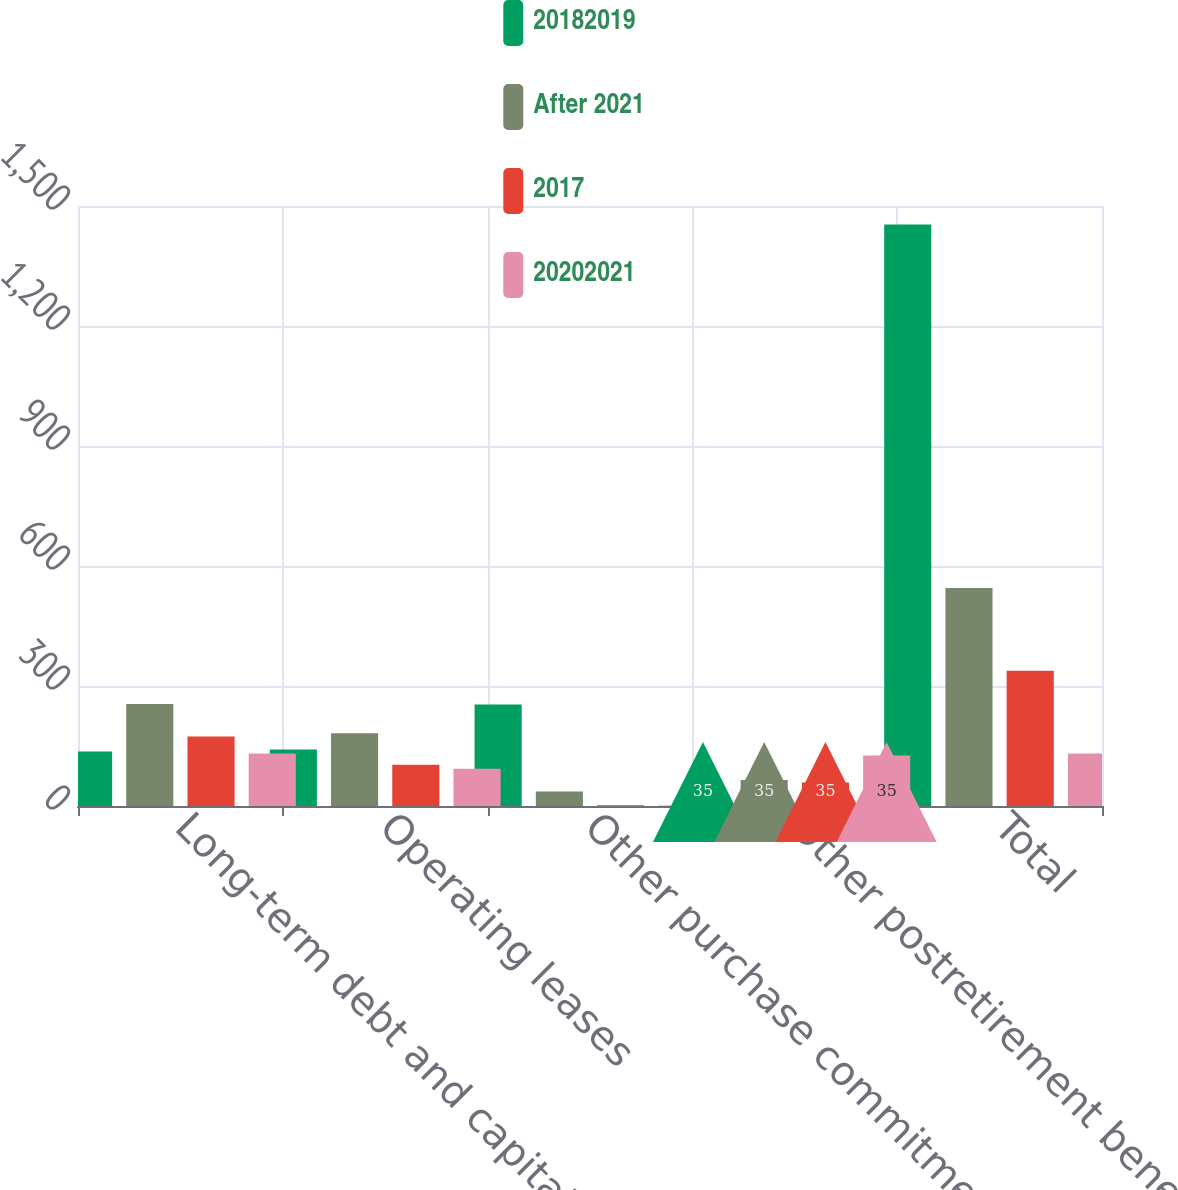Convert chart. <chart><loc_0><loc_0><loc_500><loc_500><stacked_bar_chart><ecel><fcel>Long-term debt and capital<fcel>Operating leases<fcel>Other purchase commitments<fcel>Other postretirement benefits<fcel>Total<nl><fcel>20182019<fcel>136<fcel>141<fcel>254<fcel>35<fcel>1454<nl><fcel>After 2021<fcel>255<fcel>182<fcel>36<fcel>65<fcel>545<nl><fcel>2017<fcel>174<fcel>103<fcel>2<fcel>59<fcel>338<nl><fcel>20202021<fcel>131<fcel>93<fcel>1<fcel>126<fcel>131<nl></chart> 